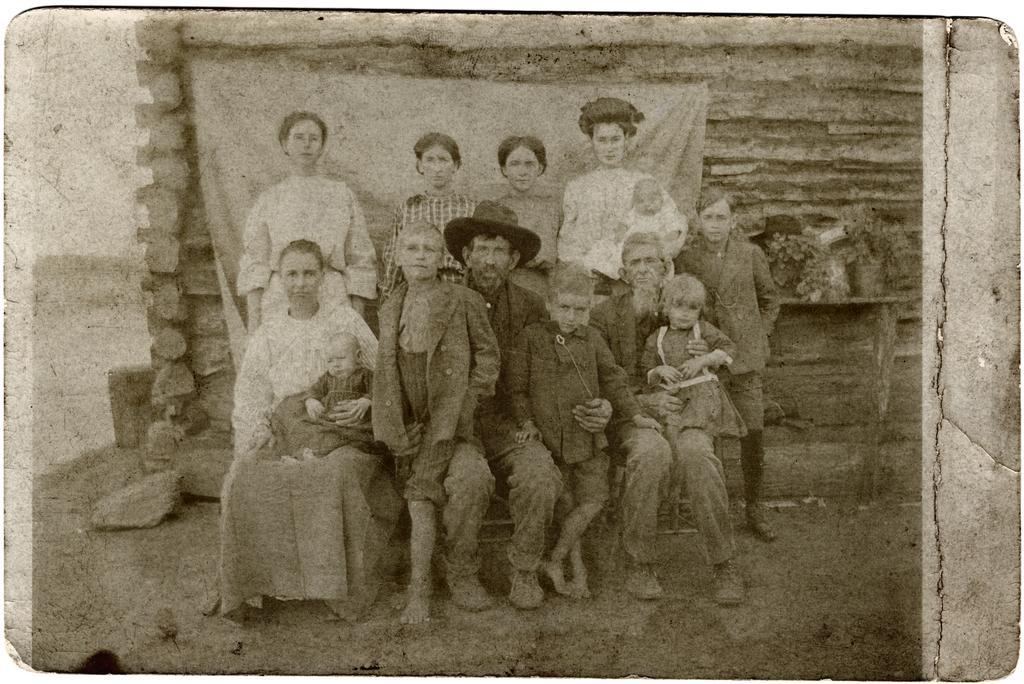In one or two sentences, can you explain what this image depicts? In this image we can see there is a black and white photo. In this photo we can see there are a few people sitting and few are standing with a smile, behind them there is a wall with bricks, in front of the wall there is a curtain. 